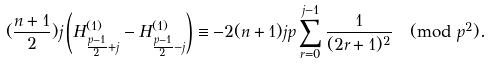<formula> <loc_0><loc_0><loc_500><loc_500>( \frac { n + 1 } { 2 } ) j \left ( H _ { \frac { p - 1 } { 2 } + j } ^ { ( 1 ) } - H _ { \frac { p - 1 } { 2 } - j } ^ { ( 1 ) } \right ) \equiv - 2 ( n + 1 ) j p \sum _ { r = 0 } ^ { j - 1 } \frac { 1 } { ( 2 r + 1 ) ^ { 2 } } \pmod { p ^ { 2 } } .</formula> 